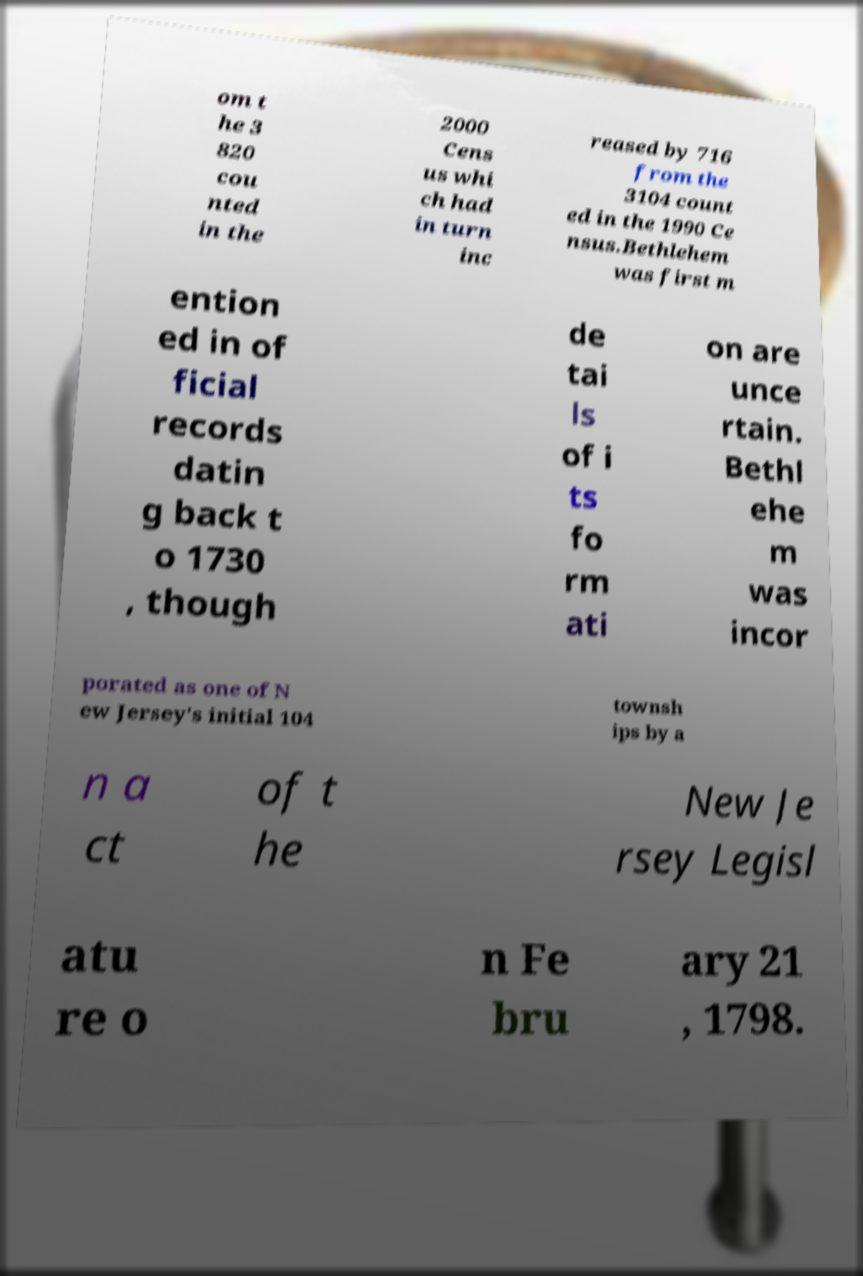What messages or text are displayed in this image? I need them in a readable, typed format. om t he 3 820 cou nted in the 2000 Cens us whi ch had in turn inc reased by 716 from the 3104 count ed in the 1990 Ce nsus.Bethlehem was first m ention ed in of ficial records datin g back t o 1730 , though de tai ls of i ts fo rm ati on are unce rtain. Bethl ehe m was incor porated as one of N ew Jersey's initial 104 townsh ips by a n a ct of t he New Je rsey Legisl atu re o n Fe bru ary 21 , 1798. 